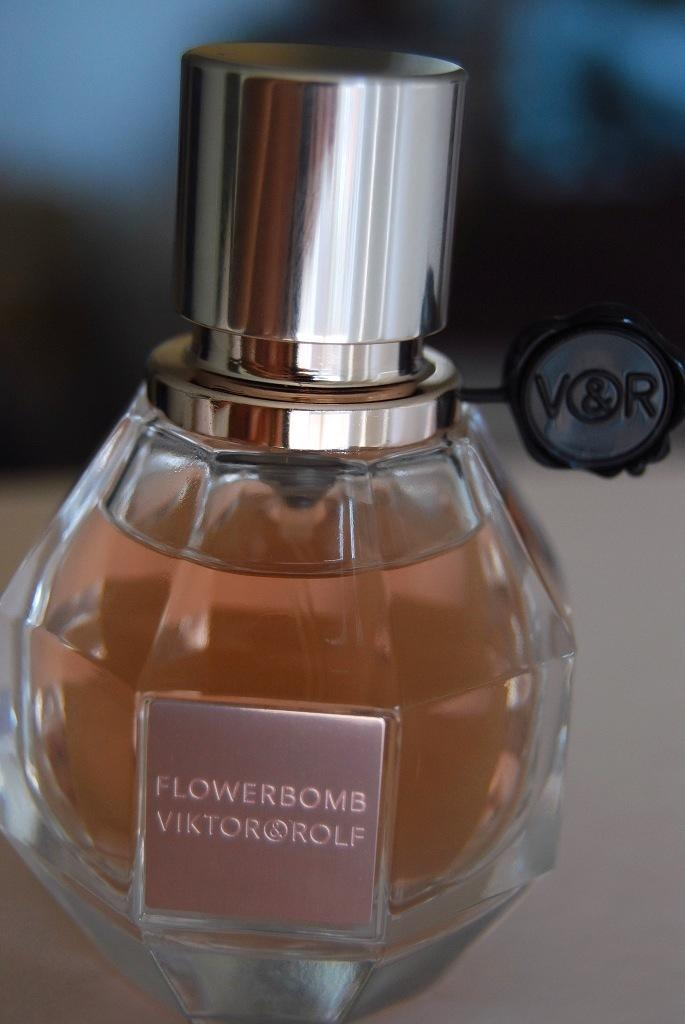<image>
Offer a succinct explanation of the picture presented. A perfume, made by Viktor & Rolf, is called Flowerbomb./ 